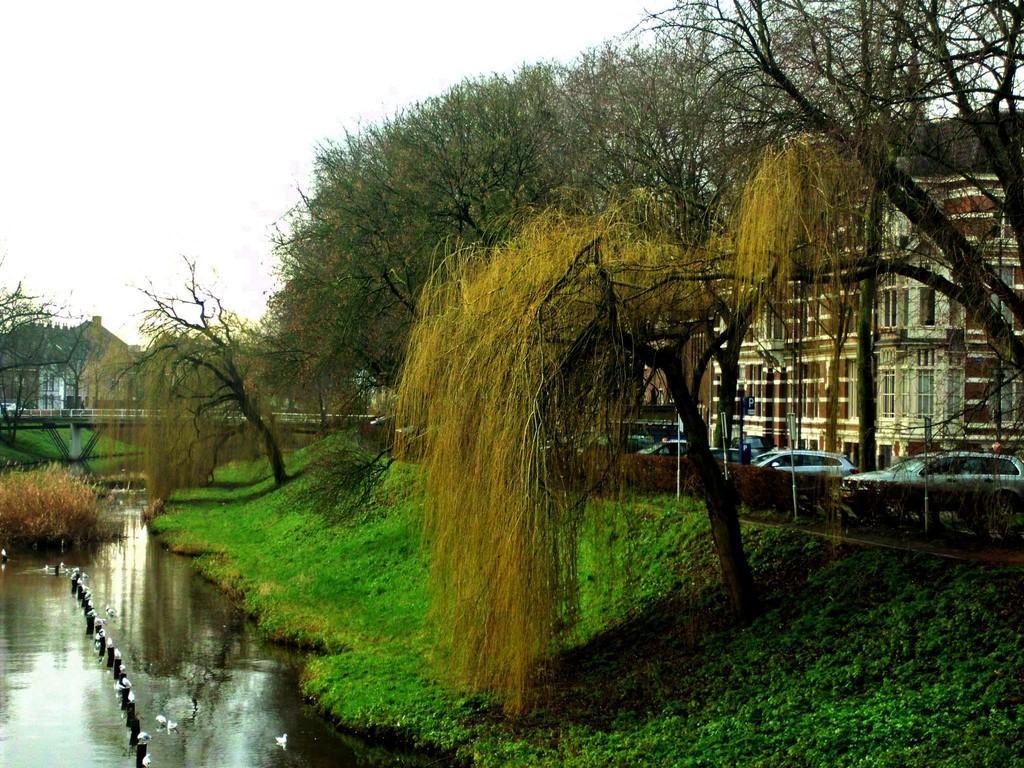Describe this image in one or two sentences. In this image we can see buildings, trees, motor vehicles on the road, grass, birds, barrier poles, bridge over a river, hills and sky. 